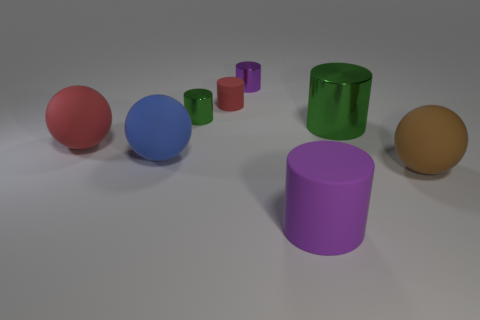Subtract 2 cylinders. How many cylinders are left? 3 Subtract all tiny green metal cylinders. How many cylinders are left? 4 Subtract all red cylinders. How many cylinders are left? 4 Subtract all yellow cylinders. Subtract all green cubes. How many cylinders are left? 5 Add 1 big red matte cylinders. How many objects exist? 9 Subtract all balls. How many objects are left? 5 Subtract all big purple cylinders. Subtract all tiny purple shiny things. How many objects are left? 6 Add 2 tiny red things. How many tiny red things are left? 3 Add 8 rubber cylinders. How many rubber cylinders exist? 10 Subtract 1 blue balls. How many objects are left? 7 